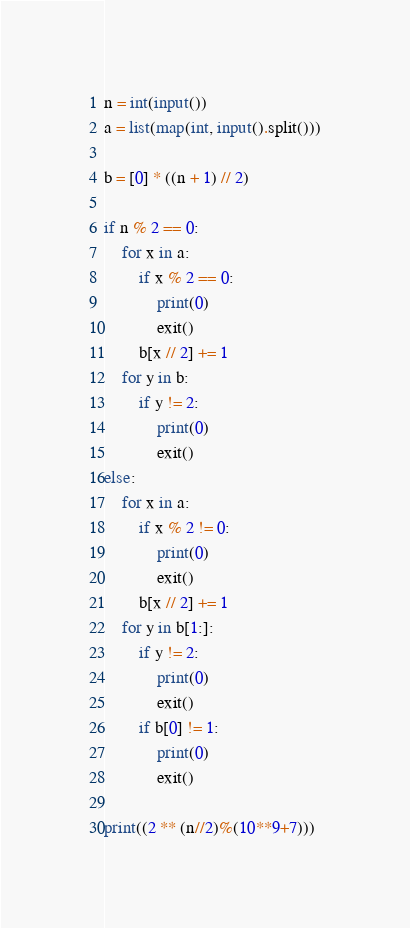<code> <loc_0><loc_0><loc_500><loc_500><_Python_>n = int(input())
a = list(map(int, input().split()))

b = [0] * ((n + 1) // 2)

if n % 2 == 0:
    for x in a:
        if x % 2 == 0:
            print(0)
            exit()
        b[x // 2] += 1
    for y in b:
        if y != 2:
            print(0)
            exit()
else:
    for x in a:
        if x % 2 != 0:
            print(0)
            exit()
        b[x // 2] += 1
    for y in b[1:]:
        if y != 2:
            print(0)
            exit()
        if b[0] != 1:
            print(0)
            exit()

print((2 ** (n//2)%(10**9+7)))
</code> 